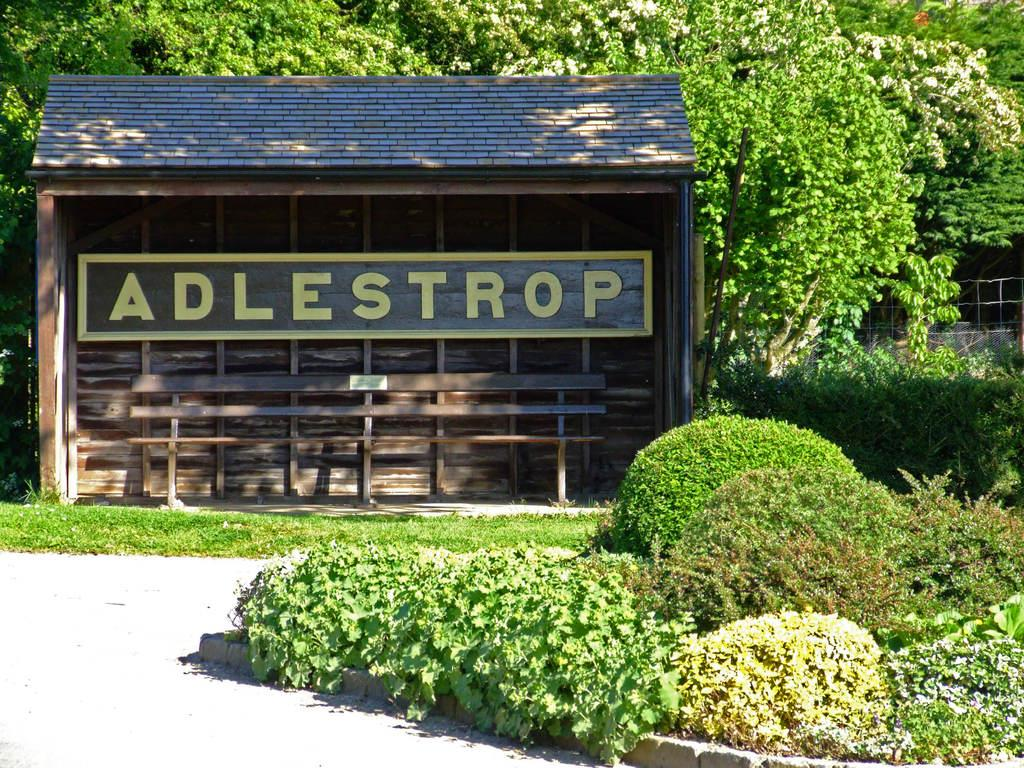What type of living organisms can be seen in the image? Plants can be seen in the image. What structure is visible in the background of the image? There is a shelter in the background of the image. What type of vegetation is behind the shelter in the image? There are trees behind the shelter in the image. What things can be seen stopping to rest in the image? There are no things or objects in the image that can be seen stopping to rest. 